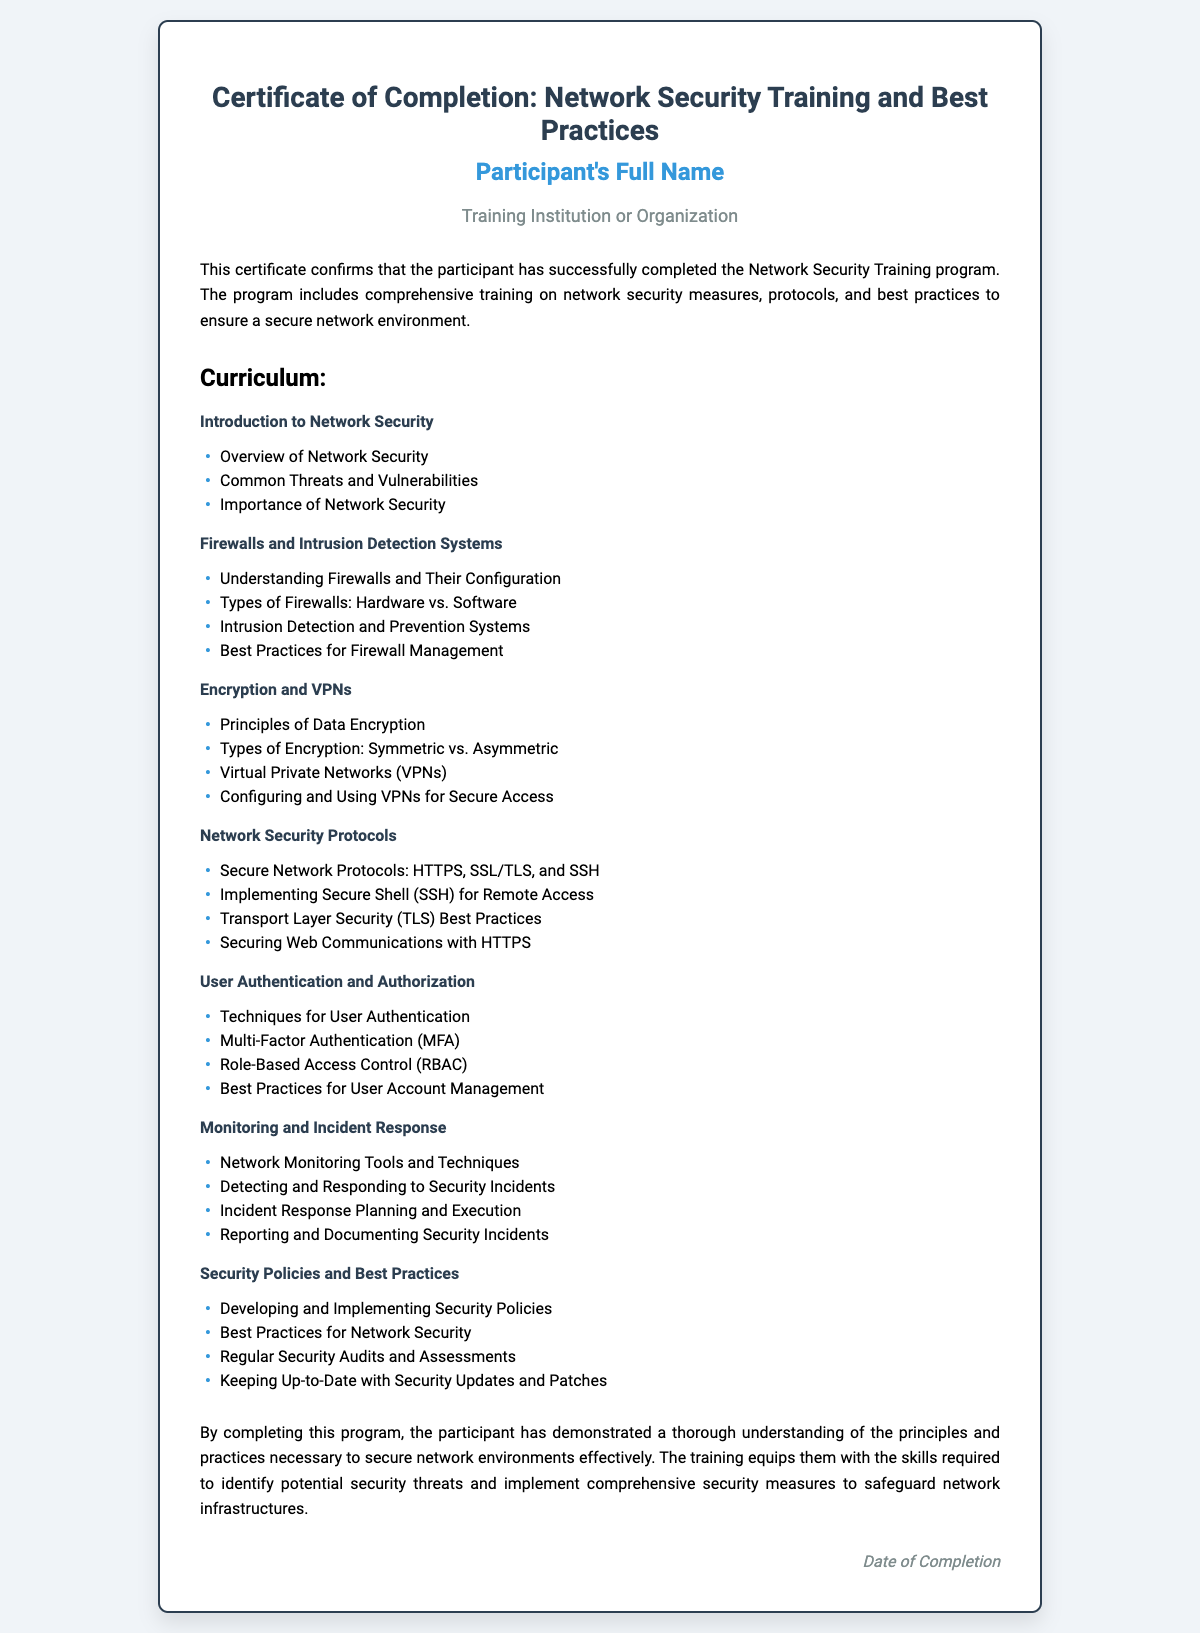What is the title of the certificate? The title of the certificate is prominently displayed at the top of the document.
Answer: Certificate of Completion: Network Security Training and Best Practices Who is the participant? The participant's name is indicated in a specific section of the document.
Answer: Participant's Full Name What organization provided the training? The name of the training institution or organization is mentioned just below the participant's name.
Answer: Training Institution or Organization What is the first module of the curriculum? The curriculum lists various modules, starting with the first one.
Answer: Introduction to Network Security How many topics are under "Firewalls and Intrusion Detection Systems"? The number of topics can be counted in the list provided under that module.
Answer: Four What is a key aspect of the conclusion? The conclusion summarizes the participant's understanding and skills developed through the training.
Answer: Understanding of the principles and practices necessary to secure network environments What is mentioned about security audits in the curriculum? The curriculum outlines specific best practices related to security, which includes regular audits.
Answer: Regular Security Audits and Assessments When was the completion date? The completion date is noted at the bottom of the document in a dedicated section.
Answer: Date of Completion 